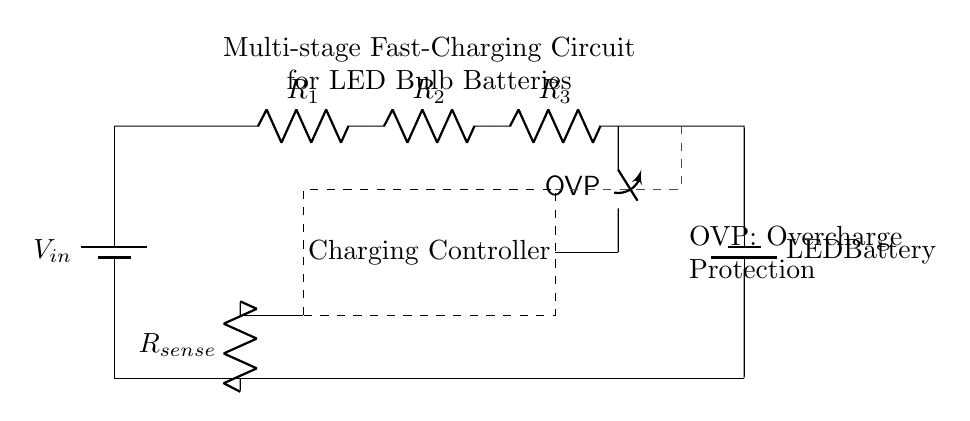What is the type of power source used? The power source is identified as a battery labeled 'V_in', which visually confirms that it is a DC battery supplying power to the circuit.
Answer: battery What component provides overcharge protection? The component labeled 'OVP' is a switch in the circuit that serves as the overcharge protection mechanism. The label indicates its function clearly.
Answer: OVP How many resistors are in the charging stage? There are three resistors labeled 'R_1', 'R_2', and 'R_3' in the circuit diagram, indicating the number of resistors in the charging stage.
Answer: three What is the function of 'R_sense'? 'R_sense' is a resistor used for current sensing in the circuit, as indicated by its label. This allows for monitoring the charging current flowing through the circuit.
Answer: current sensing What does the dashed rectangle represent? The dashed rectangle encapsulates the area labeled 'Charging Controller', indicating that this section of the circuit is responsible for managing the charging process of the LED bulb battery.
Answer: Charging Controller What is connected to the battery? The 'LED Battery' is connected at the lower part of the circuit, confirming that it is the component being charged in this circuit.
Answer: LED Battery 